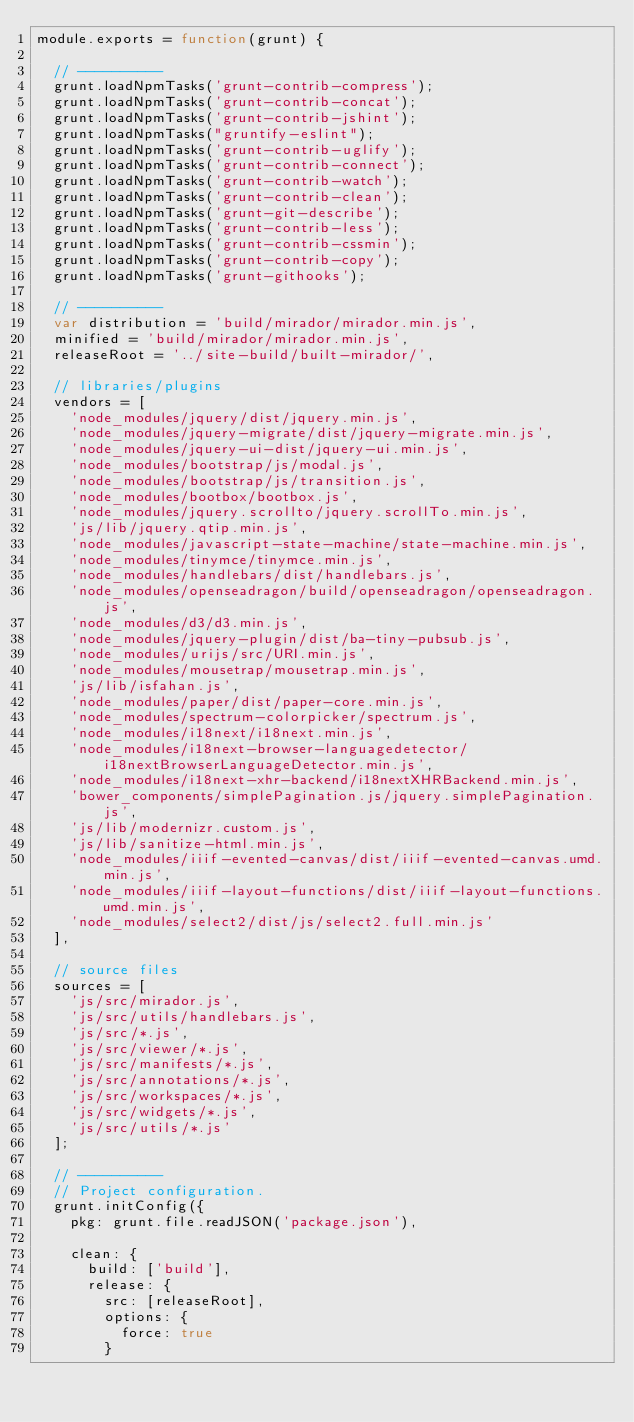<code> <loc_0><loc_0><loc_500><loc_500><_JavaScript_>module.exports = function(grunt) {

  // ----------
  grunt.loadNpmTasks('grunt-contrib-compress');
  grunt.loadNpmTasks('grunt-contrib-concat');
  grunt.loadNpmTasks('grunt-contrib-jshint');
  grunt.loadNpmTasks("gruntify-eslint");
  grunt.loadNpmTasks('grunt-contrib-uglify');
  grunt.loadNpmTasks('grunt-contrib-connect');
  grunt.loadNpmTasks('grunt-contrib-watch');
  grunt.loadNpmTasks('grunt-contrib-clean');
  grunt.loadNpmTasks('grunt-git-describe');
  grunt.loadNpmTasks('grunt-contrib-less');
  grunt.loadNpmTasks('grunt-contrib-cssmin');
  grunt.loadNpmTasks('grunt-contrib-copy');
  grunt.loadNpmTasks('grunt-githooks');

  // ----------
  var distribution = 'build/mirador/mirador.min.js',
  minified = 'build/mirador/mirador.min.js',
  releaseRoot = '../site-build/built-mirador/',

  // libraries/plugins
  vendors = [
    'node_modules/jquery/dist/jquery.min.js',
    'node_modules/jquery-migrate/dist/jquery-migrate.min.js',
    'node_modules/jquery-ui-dist/jquery-ui.min.js',
    'node_modules/bootstrap/js/modal.js',
    'node_modules/bootstrap/js/transition.js',
    'node_modules/bootbox/bootbox.js',
    'node_modules/jquery.scrollto/jquery.scrollTo.min.js',
    'js/lib/jquery.qtip.min.js',
    'node_modules/javascript-state-machine/state-machine.min.js',
    'node_modules/tinymce/tinymce.min.js',
    'node_modules/handlebars/dist/handlebars.js',
    'node_modules/openseadragon/build/openseadragon/openseadragon.js',
    'node_modules/d3/d3.min.js',
    'node_modules/jquery-plugin/dist/ba-tiny-pubsub.js',
    'node_modules/urijs/src/URI.min.js',
    'node_modules/mousetrap/mousetrap.min.js',
    'js/lib/isfahan.js',
    'node_modules/paper/dist/paper-core.min.js',
    'node_modules/spectrum-colorpicker/spectrum.js',
    'node_modules/i18next/i18next.min.js',
    'node_modules/i18next-browser-languagedetector/i18nextBrowserLanguageDetector.min.js',
    'node_modules/i18next-xhr-backend/i18nextXHRBackend.min.js',
    'bower_components/simplePagination.js/jquery.simplePagination.js',
    'js/lib/modernizr.custom.js',
    'js/lib/sanitize-html.min.js',
    'node_modules/iiif-evented-canvas/dist/iiif-evented-canvas.umd.min.js',
    'node_modules/iiif-layout-functions/dist/iiif-layout-functions.umd.min.js',
    'node_modules/select2/dist/js/select2.full.min.js'
  ],

  // source files
  sources = [
    'js/src/mirador.js',
    'js/src/utils/handlebars.js',
    'js/src/*.js',
    'js/src/viewer/*.js',
    'js/src/manifests/*.js',
    'js/src/annotations/*.js',
    'js/src/workspaces/*.js',
    'js/src/widgets/*.js',
    'js/src/utils/*.js'
  ];

  // ----------
  // Project configuration.
  grunt.initConfig({
    pkg: grunt.file.readJSON('package.json'),

    clean: {
      build: ['build'],
      release: {
        src: [releaseRoot],
        options: {
          force: true
        }</code> 